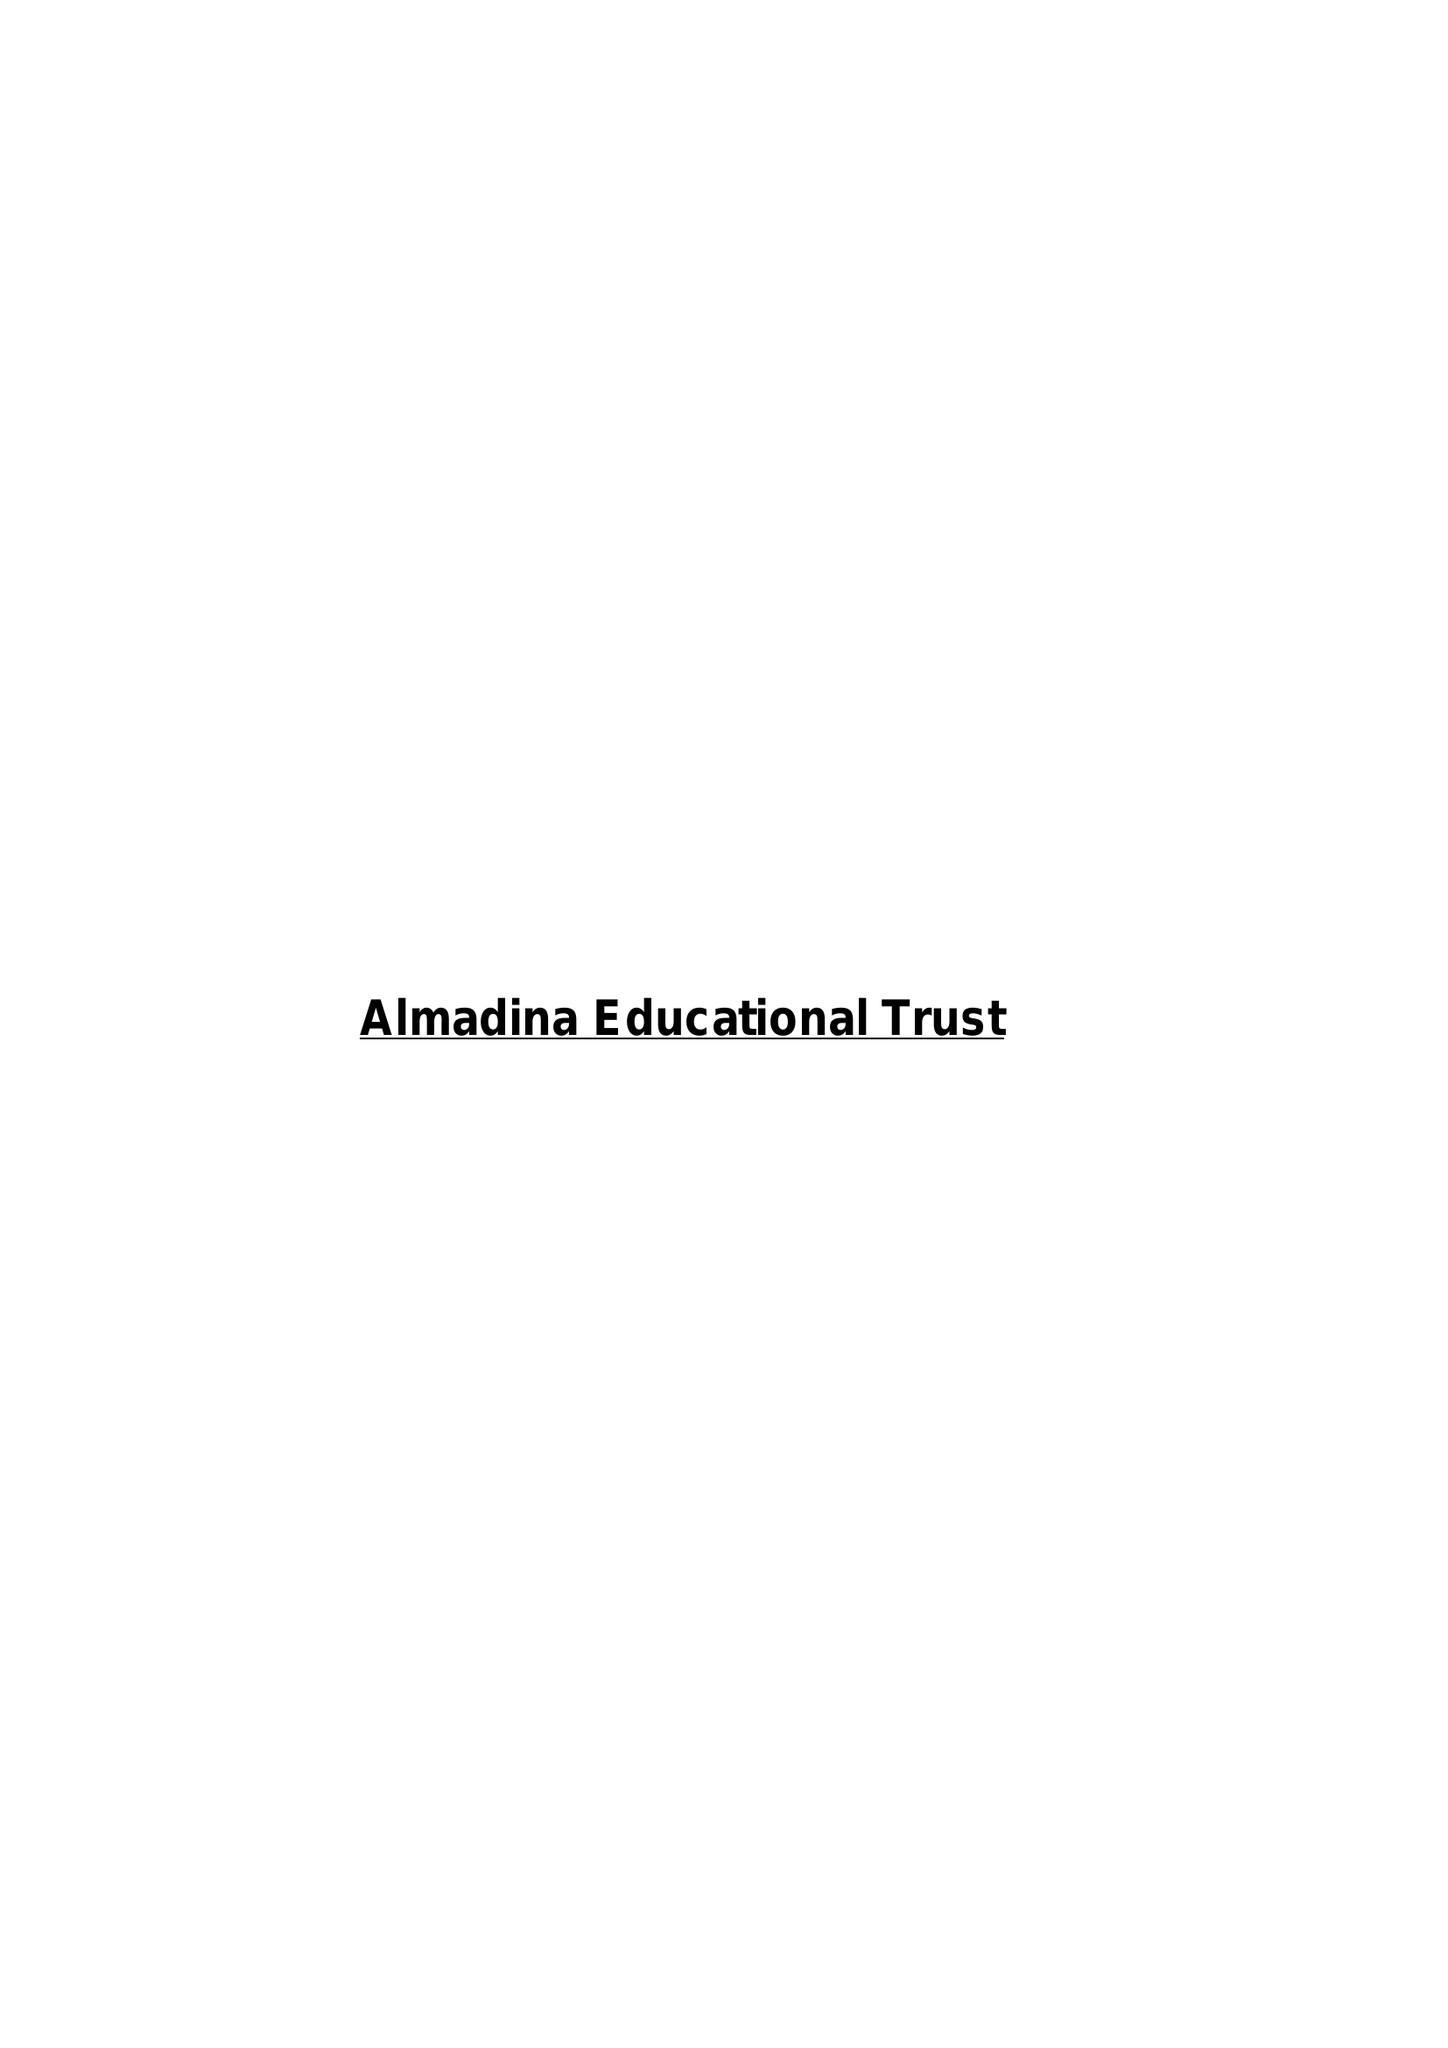What is the value for the address__street_line?
Answer the question using a single word or phrase. 11 GREENWOOD STREET 